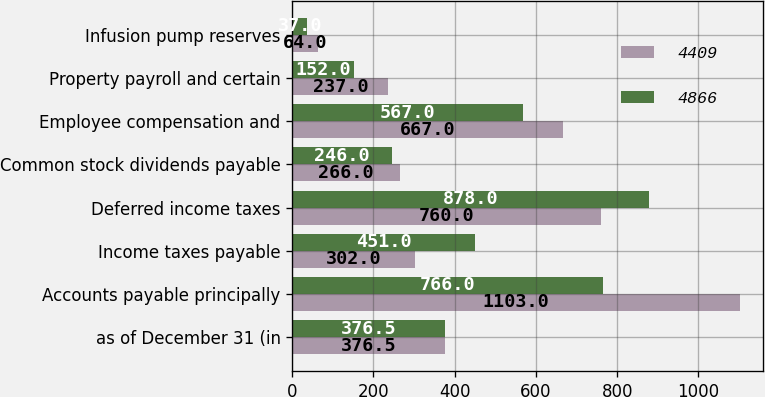<chart> <loc_0><loc_0><loc_500><loc_500><stacked_bar_chart><ecel><fcel>as of December 31 (in<fcel>Accounts payable principally<fcel>Income taxes payable<fcel>Deferred income taxes<fcel>Common stock dividends payable<fcel>Employee compensation and<fcel>Property payroll and certain<fcel>Infusion pump reserves<nl><fcel>4409<fcel>376.5<fcel>1103<fcel>302<fcel>760<fcel>266<fcel>667<fcel>237<fcel>64<nl><fcel>4866<fcel>376.5<fcel>766<fcel>451<fcel>878<fcel>246<fcel>567<fcel>152<fcel>37<nl></chart> 